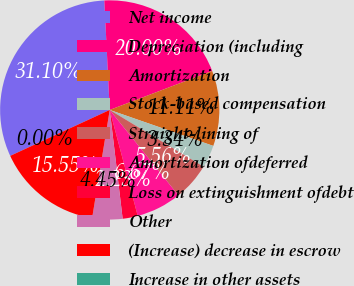Convert chart. <chart><loc_0><loc_0><loc_500><loc_500><pie_chart><fcel>Net income<fcel>Depreciation (including<fcel>Amortization<fcel>Stock-based compensation<fcel>Straight-lining of<fcel>Amortization ofdeferred<fcel>Loss on extinguishment ofdebt<fcel>Other<fcel>(Increase) decrease in escrow<fcel>Increase in other assets<nl><fcel>31.1%<fcel>20.0%<fcel>11.11%<fcel>3.34%<fcel>5.56%<fcel>6.67%<fcel>2.23%<fcel>4.45%<fcel>15.55%<fcel>0.0%<nl></chart> 